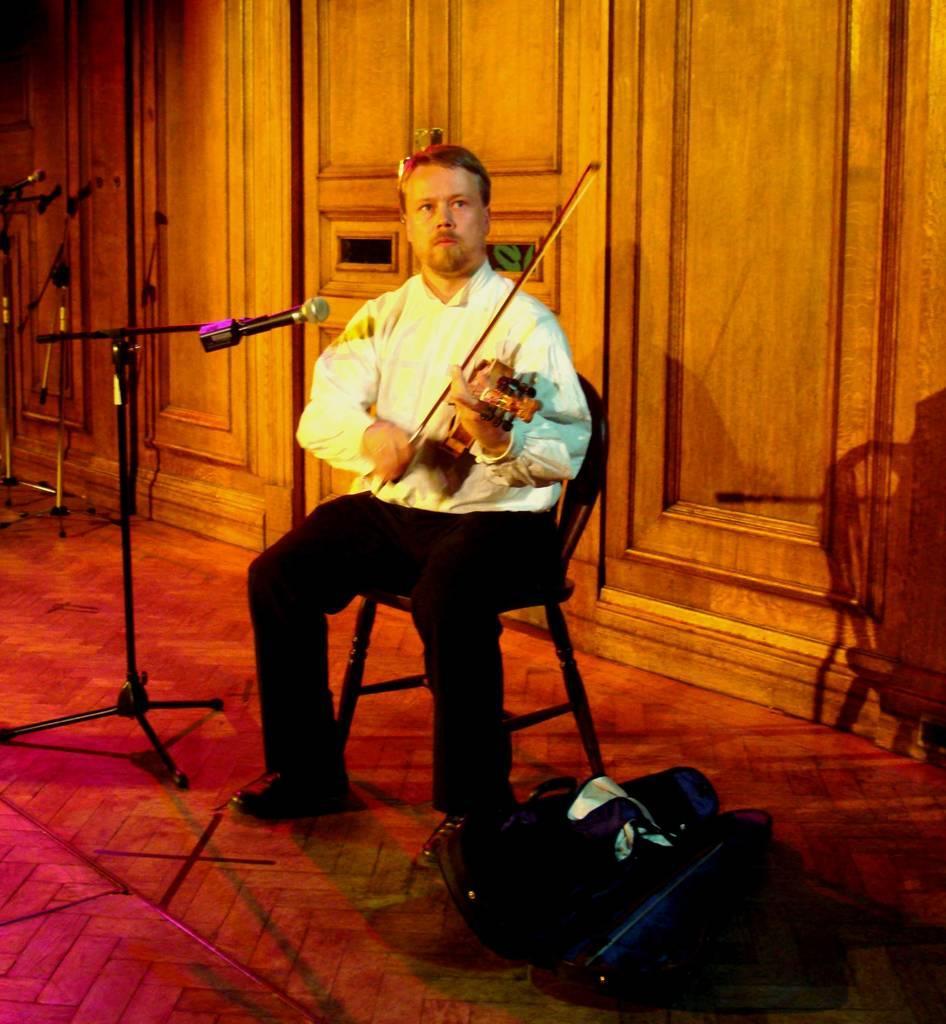Describe this image in one or two sentences. In this image, we can see a person wearing clothes and sitting on a chair. This person is playing a violin in front of the mic. There is a bag at the bottom of the image. In the background, we can see a wooden wall. 